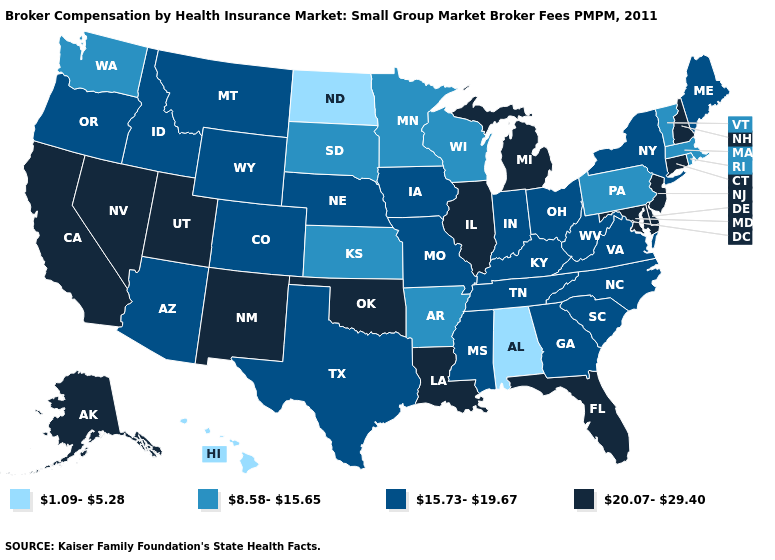Which states have the lowest value in the Northeast?
Short answer required. Massachusetts, Pennsylvania, Rhode Island, Vermont. Does the first symbol in the legend represent the smallest category?
Concise answer only. Yes. What is the value of Missouri?
Give a very brief answer. 15.73-19.67. What is the value of Nebraska?
Give a very brief answer. 15.73-19.67. What is the lowest value in the Northeast?
Short answer required. 8.58-15.65. What is the value of Iowa?
Give a very brief answer. 15.73-19.67. Among the states that border Utah , does Nevada have the highest value?
Give a very brief answer. Yes. What is the value of Oregon?
Be succinct. 15.73-19.67. Which states hav the highest value in the Northeast?
Short answer required. Connecticut, New Hampshire, New Jersey. Name the states that have a value in the range 1.09-5.28?
Quick response, please. Alabama, Hawaii, North Dakota. Does Connecticut have the highest value in the Northeast?
Keep it brief. Yes. What is the value of Arkansas?
Give a very brief answer. 8.58-15.65. Which states have the lowest value in the MidWest?
Keep it brief. North Dakota. What is the value of Oregon?
Answer briefly. 15.73-19.67. Does Colorado have the highest value in the USA?
Answer briefly. No. 